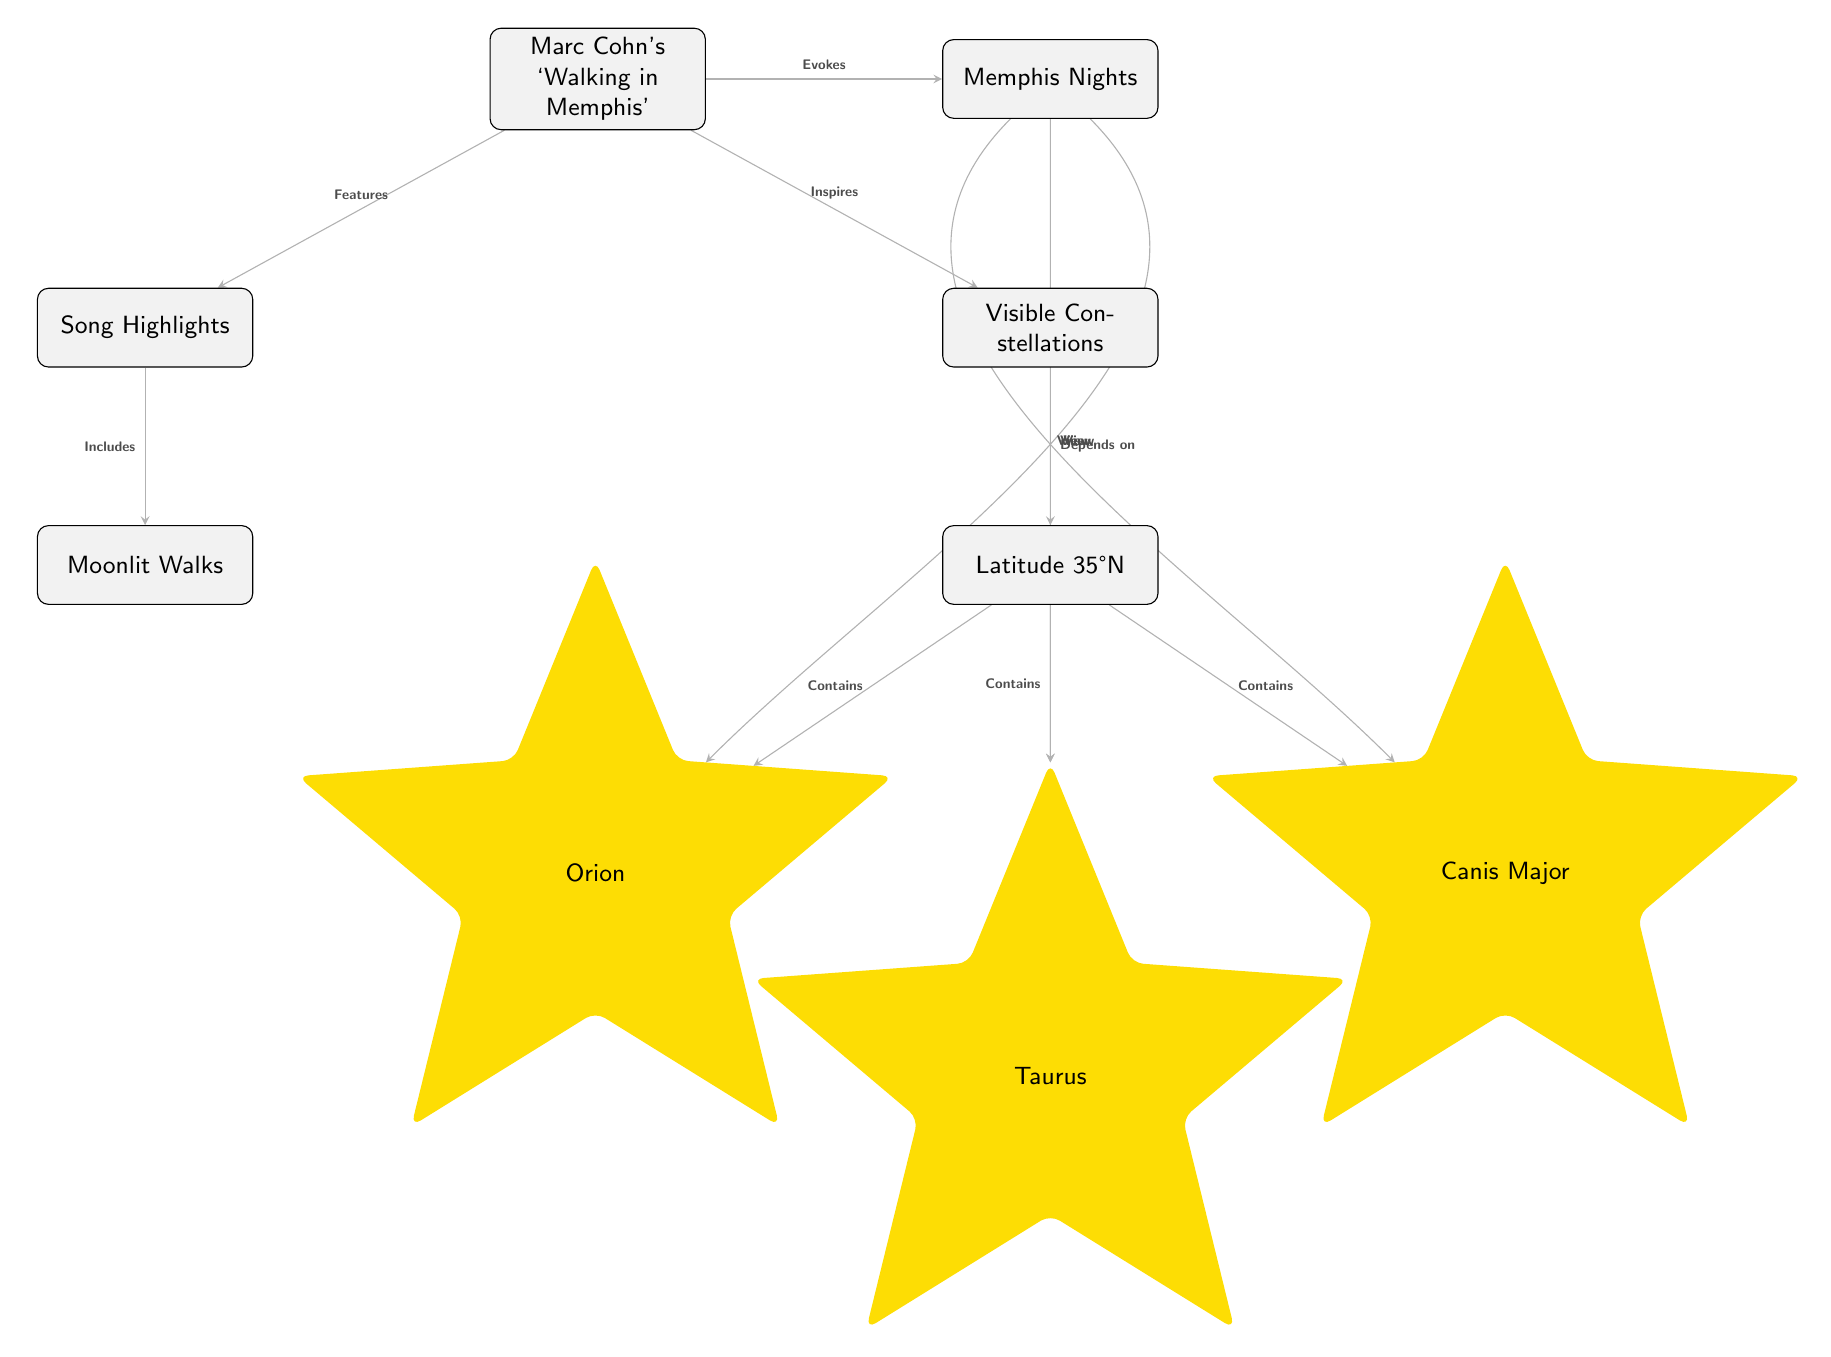What is the main title of the diagram? The title of the diagram is clearly stated at the top node, indicating the central theme around which the other elements are organized.
Answer: Marc Cohn's `Walking in Memphis` How many visible constellations are mentioned? The diagram lists three constellations that are specifically visible at the 35°N latitude, connected to the theme of the song.
Answer: 3 Which constellation is located below left of the latitude node? The diagram positions Orion directly below left of the latitude node, making it easy to identify this specific constellation's position.
Answer: Orion What are the features of Marc Cohn's song indicated in the diagram? The edge connecting the "Walking in Memphis" node to the "Song Highlights" node suggests that the song has certain features that can be explored, which are listed below.
Answer: Song Highlights What latitude is represented in the diagram? The latitude node is clearly marked within the diagram, serving as a key reference point for the visible constellations depicted.
Answer: 35°N Which constellation is associated with the moonlit walks in the song? The connection from the "Memphis Nights" node to the "Visible Constellations" along with the given view connections helps to highlight the visual associations made in the song.
Answer: Orion How does the song relate to Memphis nights? The diagram indicates a direct relationship between the song and the experience of Memphis nights, which is associated with the viewing of constellations, indicating emotional resonance.
Answer: Evokes What node is directly positioned to the right of the "Walking in Memphis" node? The immediate layout of the diagram shows that "Memphis Nights" is positioned directly to the right of the main title, reflecting its thematic relevance.
Answer: Memphis Nights Which node is contained within the latitude node? The diagram shows that the latitude node serves as a container for three constellations, establishing a relationship between geographical location and astronomy.
Answer: Orion, Taurus, Canis Major 